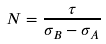Convert formula to latex. <formula><loc_0><loc_0><loc_500><loc_500>N = \frac { \tau } { \sigma _ { B } - \sigma _ { A } }</formula> 